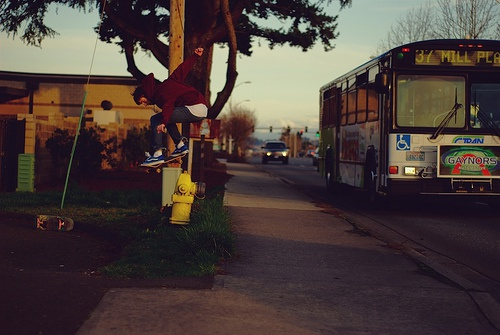Describe the objects in this image and their specific colors. I can see bus in gray, black, olive, and maroon tones, people in gray, black, maroon, and tan tones, fire hydrant in gray, olive, gold, and black tones, skateboard in gray, black, maroon, and brown tones, and truck in gray, black, maroon, and navy tones in this image. 